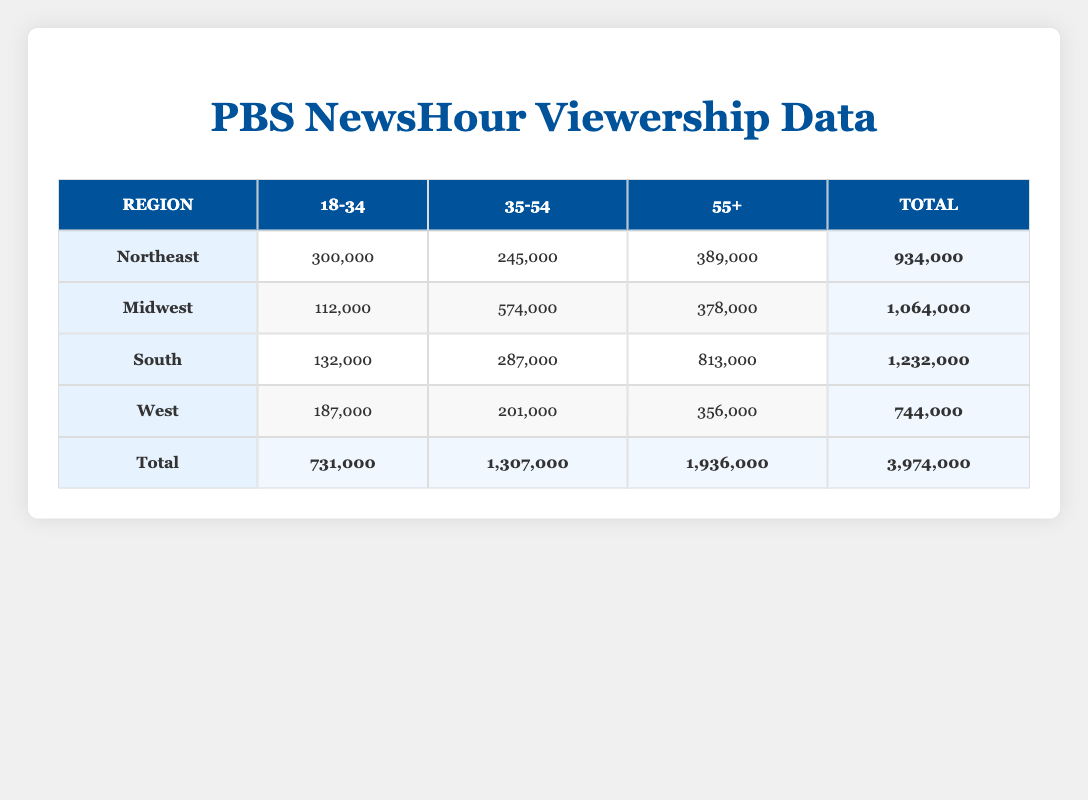What is the total viewership for the South region across all age groups? To calculate the total viewership for the South region, add the viewers from all age groups: 132,000 (18-34) + 287,000 (35-54) + 813,000 (55+) = 1,232,000.
Answer: 1,232,000 Which age group has the highest total number of viewers in the Midwest region? In the Midwest, the viewer counts for each age group are: 112,000 (18-34), 574,000 (35-54), and 378,000 (55+). The highest total is 574,000 for the 35-54 age group.
Answer: 35-54 Is the majority gender for viewers in the Northeast region female across all age groups? In the Northeast, the gender majorities for age groups are: 18-34 (Female), 35-54 (Female), and 55+ (Female). Since all age groups have a female majority, the answer is yes.
Answer: Yes What is the combined viewership of the 18-34 age group for all regions? To find the combined viewership of the 18-34 age group, sum the viewers from all regions: 300,000 (Northeast) + 112,000 (Midwest) + 132,000 (South) + 187,000 (West) = 731,000.
Answer: 731,000 In which region is the viewership for the 55+ age group the highest? The viewership for the 55+ age group in each region is: 389,000 (Northeast), 378,000 (Midwest), 813,000 (South), and 356,000 (West). The highest is 813,000 in the South.
Answer: South What is the total number of viewers across all regions for the 35-54 age group? To find the total for the 35-54 age group, add the viewers: 245,000 (Northeast) + 574,000 (Midwest) + 287,000 (South) + 201,000 (West) = 1,307,000.
Answer: 1,307,000 Did the West region have a majority male viewership for both the 18-34 and 35-54 age groups? The West region has a male majority for the 18-34 age group (true), but the 35-54 age group has a male majority as well (true). Therefore, the answer is yes.
Answer: Yes What is the average viewership of the 55+ age group across the four regions? The viewer counts for the 55+ age group are 389,000 (Northeast), 378,000 (Midwest), 813,000 (South), and 356,000 (West). The average is calculated by summing these values (1,936,000) and dividing by 4: 1,936,000/4 = 484,000.
Answer: 484,000 